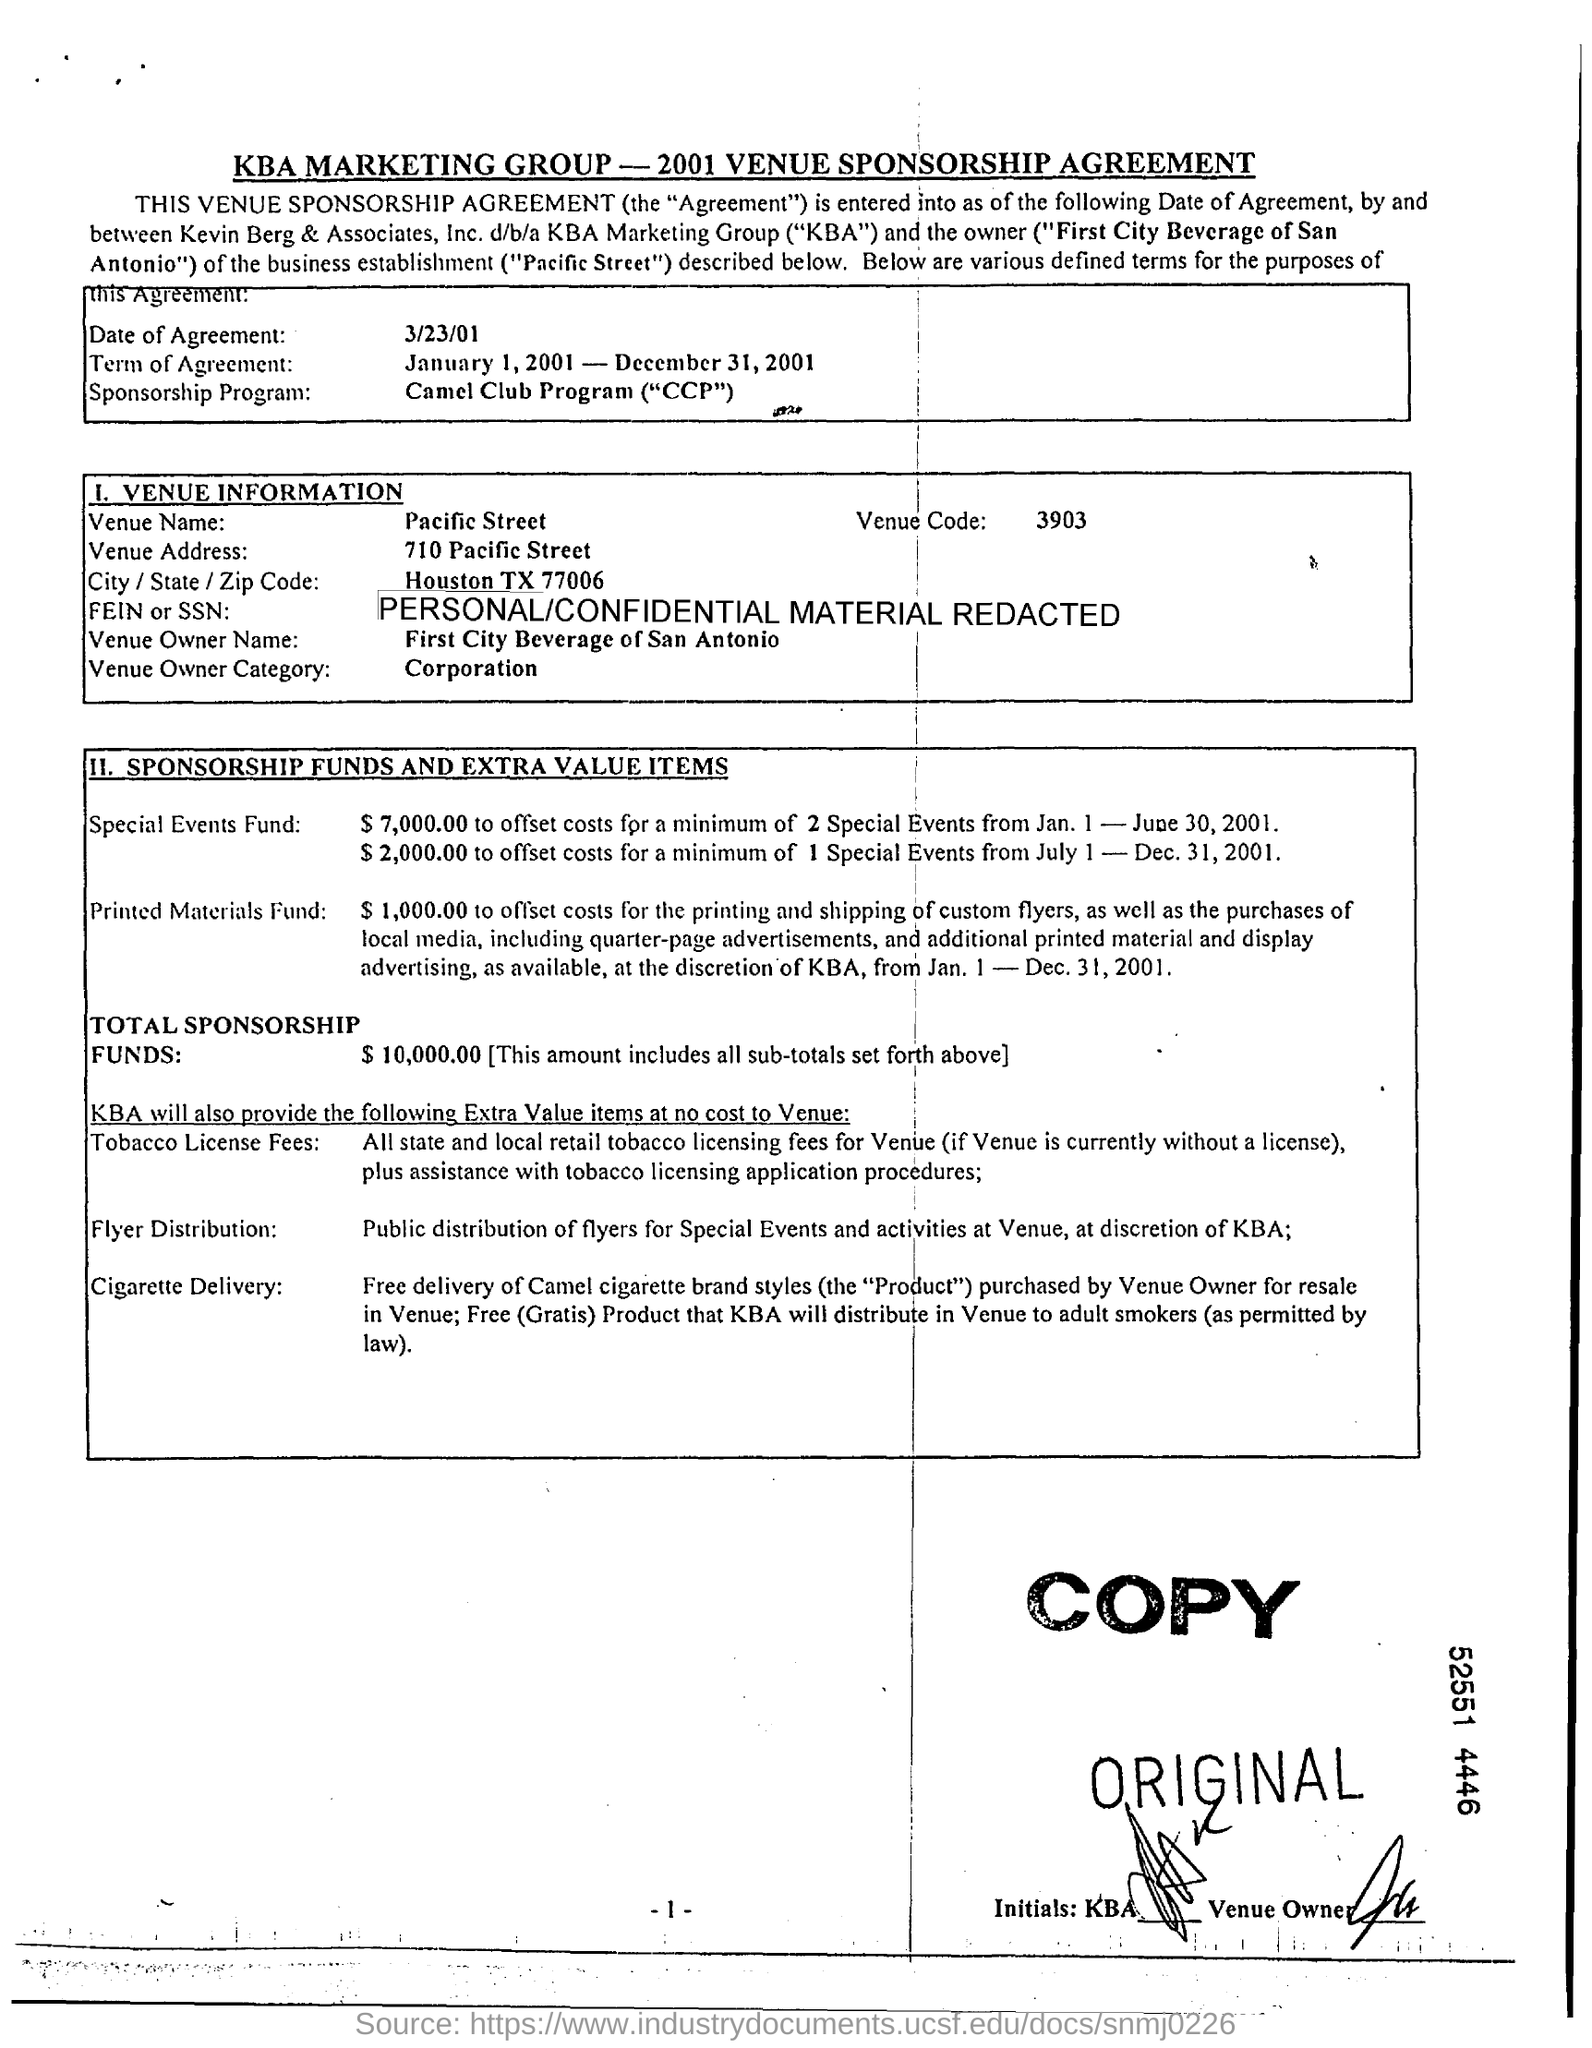Outline some significant characteristics in this image. The Venue Name is located on Pacific Street. The Venue Owner category is a classification for businesses that own the venues where events are held, such as corporations. The date of agreement is March 23, 2001. The Venue Code is 3903. 